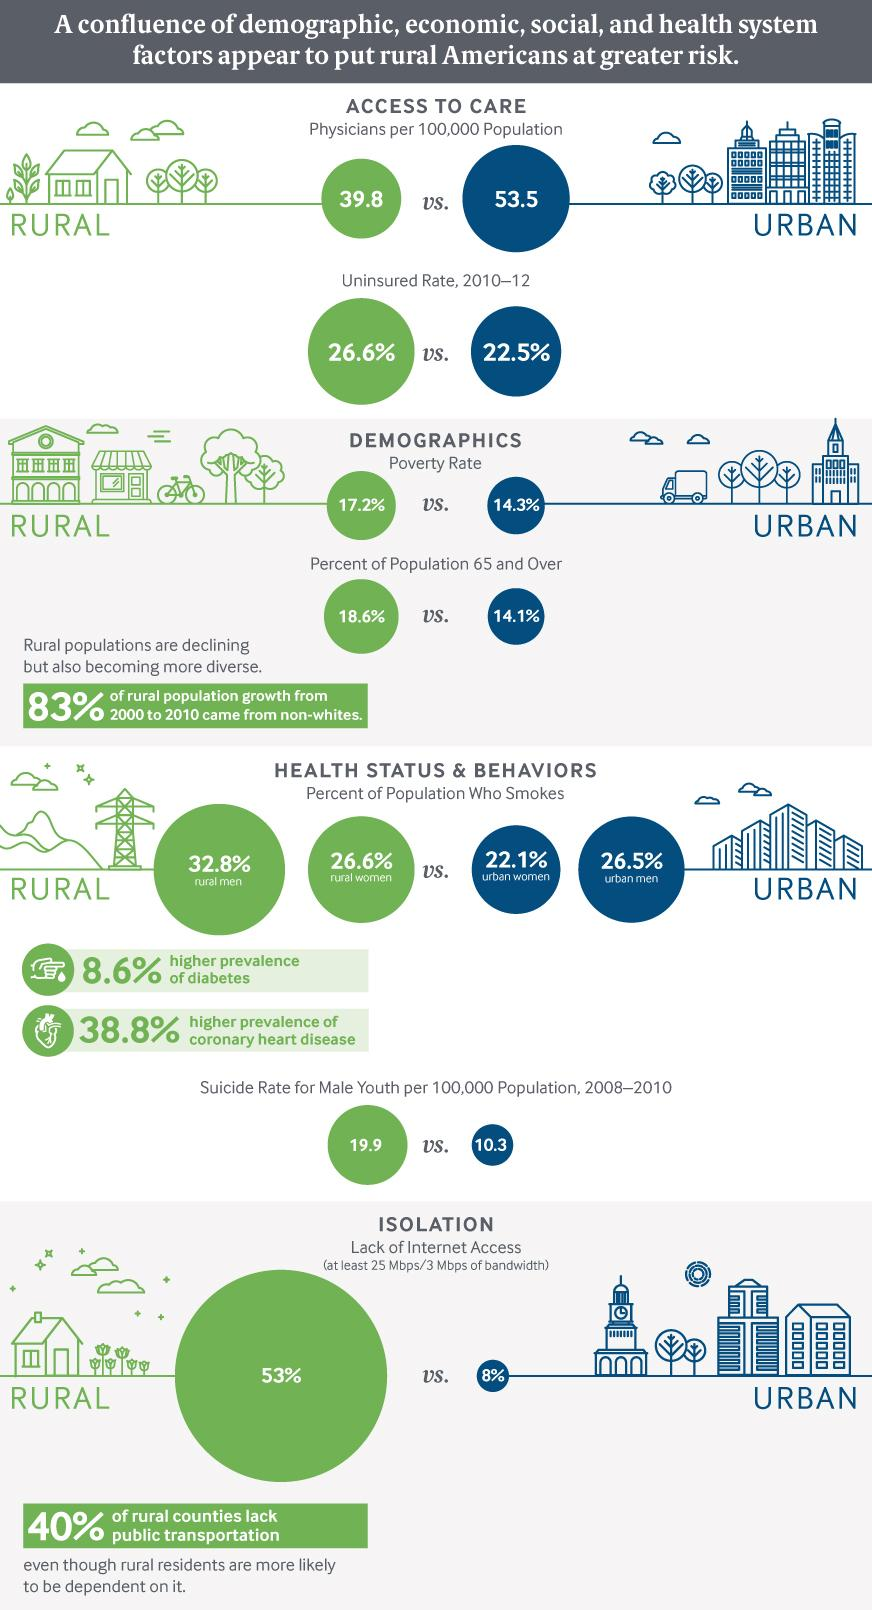Identify some key points in this picture. In urban areas, approximately 22.1% of women smoke, maintaining a habit that can have negative health consequences. According to data on Urban Americans, approximately 14.1% of the population are Senior Citizens. According to a recent survey, a significant portion of urban men in the United States do not smoke. Specifically, 73.5% of the population falls into this category. This is a positive trend as smoking is a harmful habit that can lead to various health problems. In the period between 2010 and 2012, it was found that 22.5% of the urban population had not taken insurance. The color code that is associated with the urban population is red, green, blue, and black. Specifically, blue is the color that is most commonly associated with the urban population. 